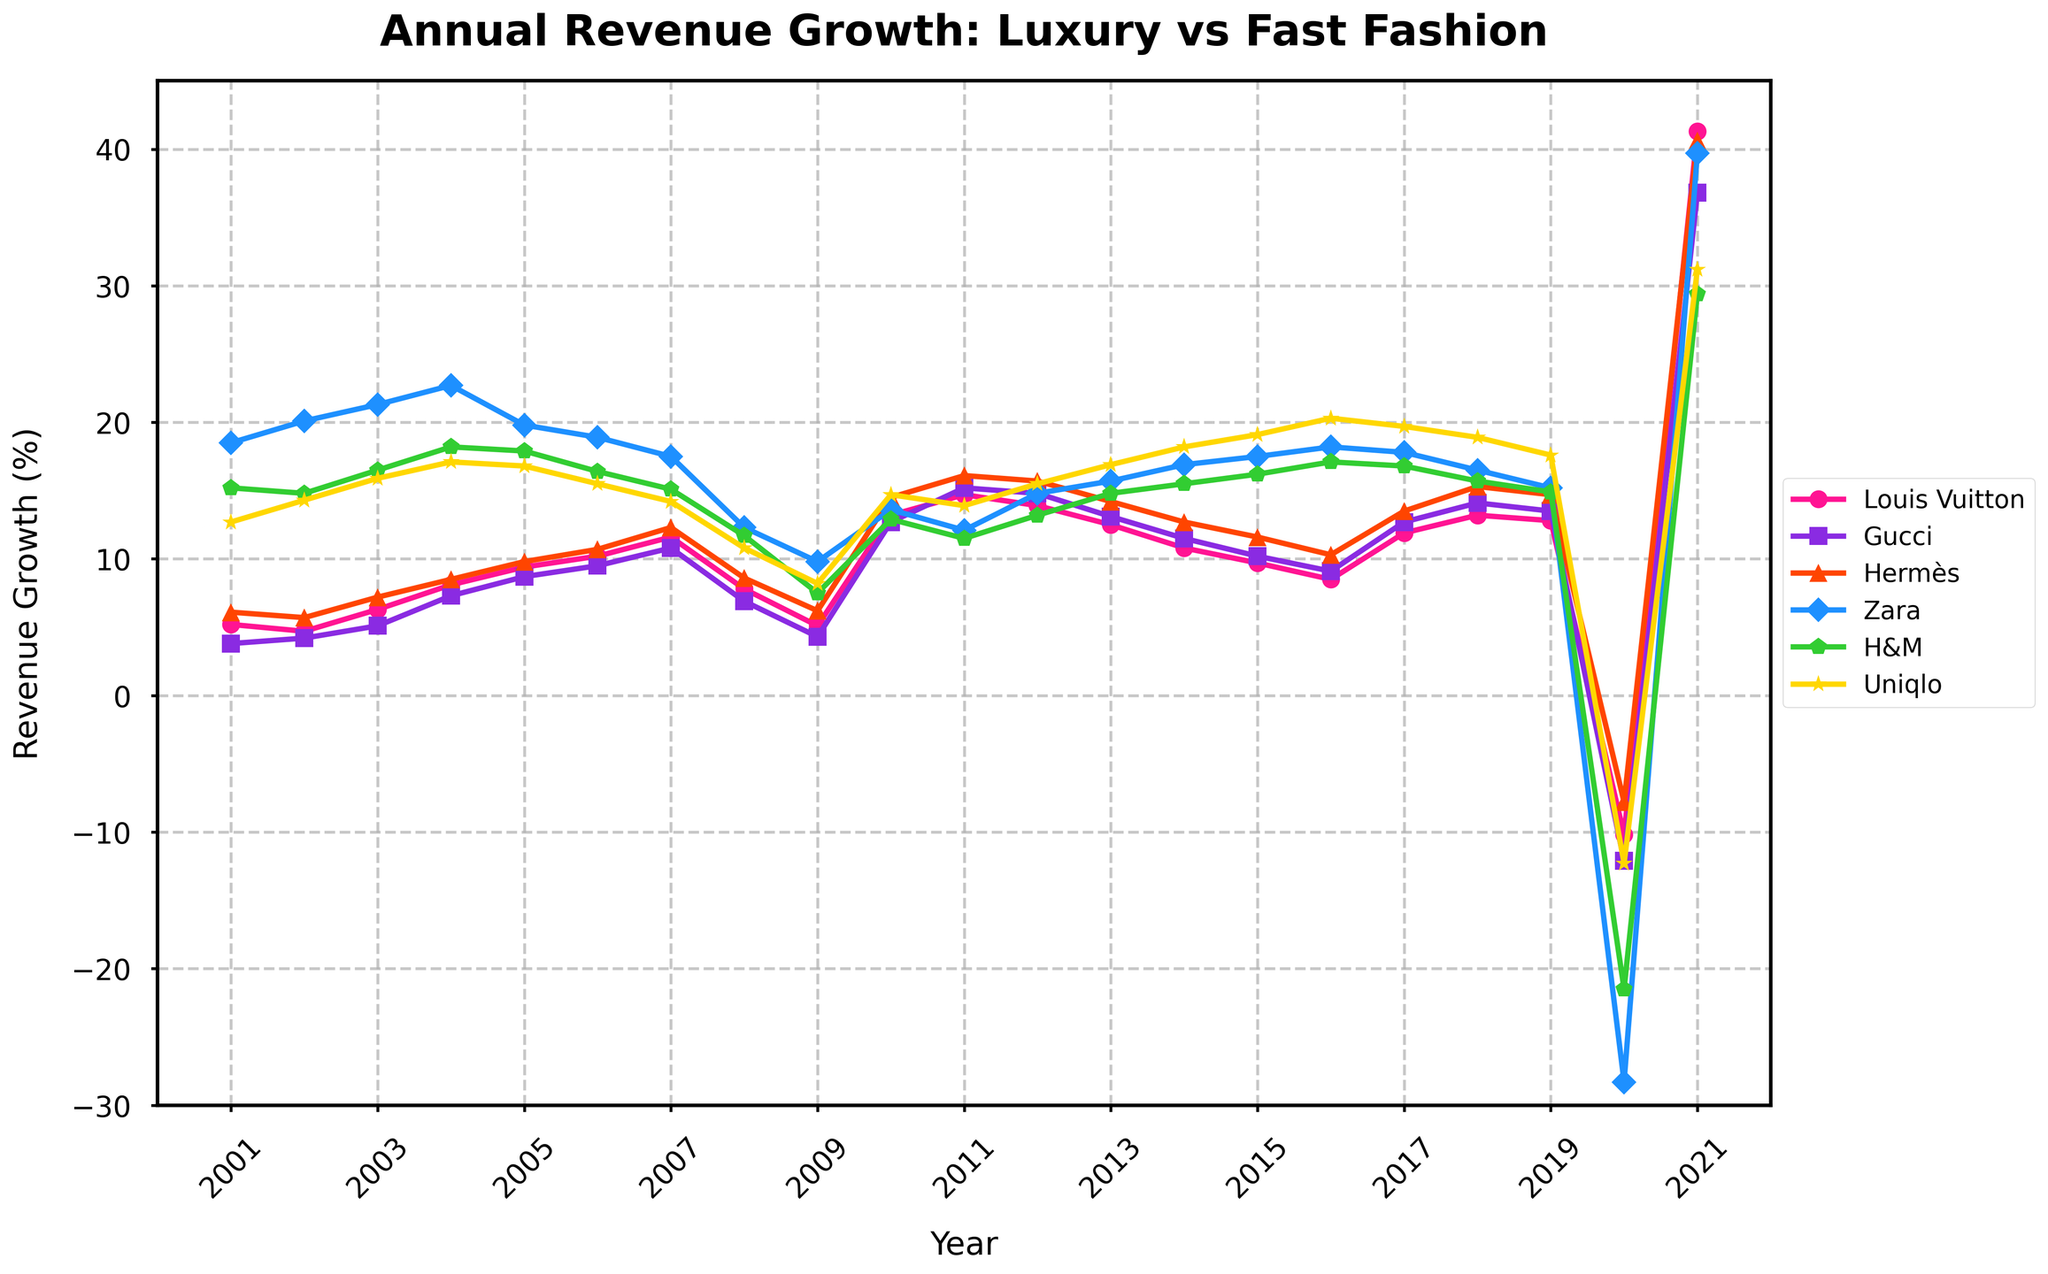What's the general trend of revenue growth for Louis Vuitton between 2001 and 2021? By observing the plot, the revenue growth for Louis Vuitton generally shows an upward trend. Starting from 5.2% in 2001, it peaks around 14.7% in 2011, experiences some fluctuations, sharp decline in 2020, and then a substantial increase to 41.3% in 2021.
Answer: Upward trend Which year shows the most significant revenue drop for fast fashion retailers? Viewing the plot, the largest revenue drop for fast fashion retailers (Zara, H&M, and Uniqlo) occurs in 2020, where Zara's revenue drops by 28.3%, H&M's by 21.5%, and Uniqlo's by 12.3%, due to the pandemic's impact.
Answer: 2020 Compare Gucci's highest revenue growth year with Hermès' highest revenue growth year. Gucci's highest revenue growth year is 2021 with 36.8%, and Hermès' highest revenue growth year is also 2021 with 40.6%. Thus, both maximize in the same year, with Hermès having a slightly higher growth.
Answer: Hermès in 2021 Which luxury fashion house had the lowest revenue growth in 2008? By examining the plot, in 2008, Gucci had the lowest revenue growth among the listed luxury fashion houses with a growth of 6.9%.
Answer: Gucci Which brand experienced the highest rebound in revenue growth from 2020 to 2021? Checking the changes from 2020 to 2021, Louis Vuitton had the highest rebound, from -10.2% to 41.3%, a 51.5% increase.
Answer: Louis Vuitton What is the difference between H&M's revenue growth in 2019 and 2020? In 2019, H&M's revenue growth is 14.9%, and in 2020, it is -21.5%. The difference is 14.9% - (-21.5%) = 36.4%.
Answer: 36.4% How does Uniqlo's revenue growth in 2020 compare to that of Zara in the same year? In 2020, Uniqlo's revenue growth is -12.3%, while Zara's is -28.3%. Uniqlo's revenue growth drop is less severe than Zara's in 2020.
Answer: Less severe Which fast fashion retailer shows a consistent upward trend from 2015 to 2019? From the plot, Uniqlo demonstrates a consistent upward trend in revenue growth from 2015 (19.1%) to 2019 (17.6%).
Answer: Uniqlo What is the average annual revenue growth for Hermès from 2011 to 2015? To calculate this, sum Hermès' annual revenue growth from 2011 (16.1%), 2012 (15.7%), 2013 (14.2%), 2014 (12.7%), and 2015 (11.6%), giving a total of 70.3%. The average is 70.3% / 5 = 14.06%.
Answer: 14.06% Which years marked the lowest revenue growth for all luxury fashion houses and fast fashion retailers combined? Observing the plot, the years with the lowest revenue growth for all combined would be 2020, where the pandemic caused significant drops across the board for both categories.
Answer: 2020 